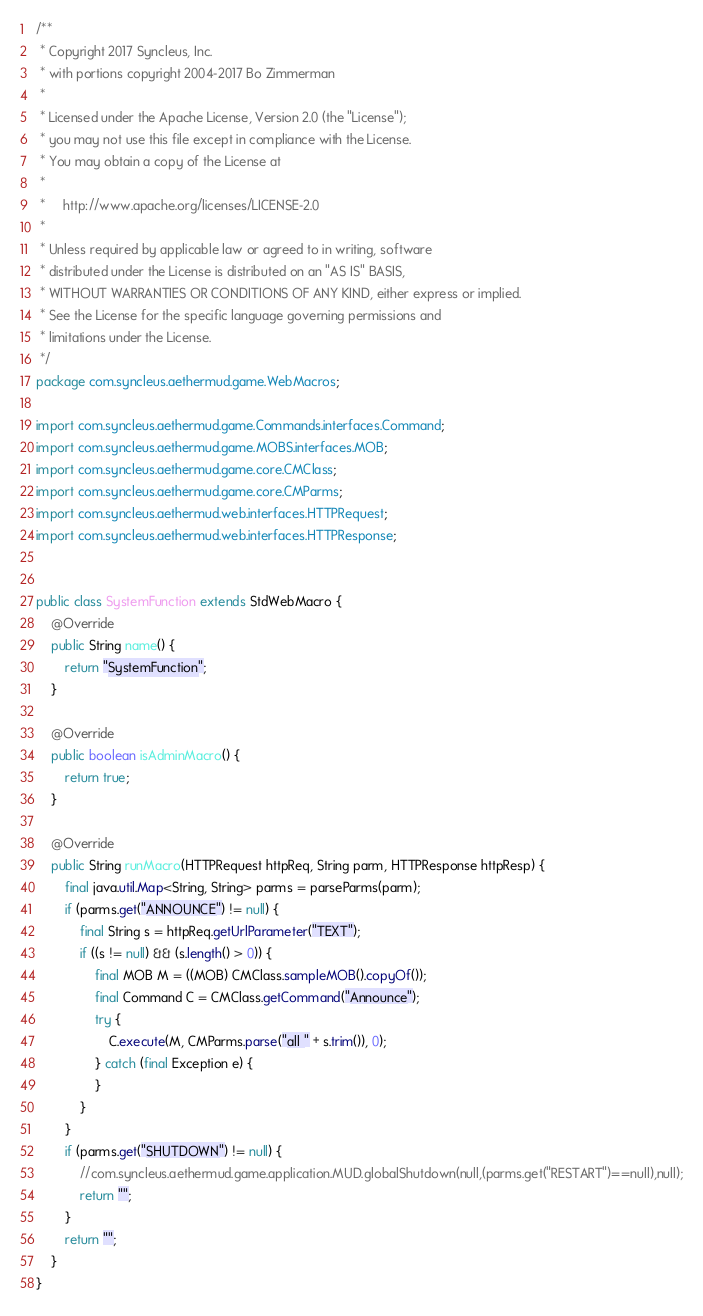<code> <loc_0><loc_0><loc_500><loc_500><_Java_>/**
 * Copyright 2017 Syncleus, Inc.
 * with portions copyright 2004-2017 Bo Zimmerman
 *
 * Licensed under the Apache License, Version 2.0 (the "License");
 * you may not use this file except in compliance with the License.
 * You may obtain a copy of the License at
 *
 *     http://www.apache.org/licenses/LICENSE-2.0
 *
 * Unless required by applicable law or agreed to in writing, software
 * distributed under the License is distributed on an "AS IS" BASIS,
 * WITHOUT WARRANTIES OR CONDITIONS OF ANY KIND, either express or implied.
 * See the License for the specific language governing permissions and
 * limitations under the License.
 */
package com.syncleus.aethermud.game.WebMacros;

import com.syncleus.aethermud.game.Commands.interfaces.Command;
import com.syncleus.aethermud.game.MOBS.interfaces.MOB;
import com.syncleus.aethermud.game.core.CMClass;
import com.syncleus.aethermud.game.core.CMParms;
import com.syncleus.aethermud.web.interfaces.HTTPRequest;
import com.syncleus.aethermud.web.interfaces.HTTPResponse;


public class SystemFunction extends StdWebMacro {
    @Override
    public String name() {
        return "SystemFunction";
    }

    @Override
    public boolean isAdminMacro() {
        return true;
    }

    @Override
    public String runMacro(HTTPRequest httpReq, String parm, HTTPResponse httpResp) {
        final java.util.Map<String, String> parms = parseParms(parm);
        if (parms.get("ANNOUNCE") != null) {
            final String s = httpReq.getUrlParameter("TEXT");
            if ((s != null) && (s.length() > 0)) {
                final MOB M = ((MOB) CMClass.sampleMOB().copyOf());
                final Command C = CMClass.getCommand("Announce");
                try {
                    C.execute(M, CMParms.parse("all " + s.trim()), 0);
                } catch (final Exception e) {
                }
            }
        }
        if (parms.get("SHUTDOWN") != null) {
            //com.syncleus.aethermud.game.application.MUD.globalShutdown(null,(parms.get("RESTART")==null),null);
            return "";
        }
        return "";
    }
}
</code> 